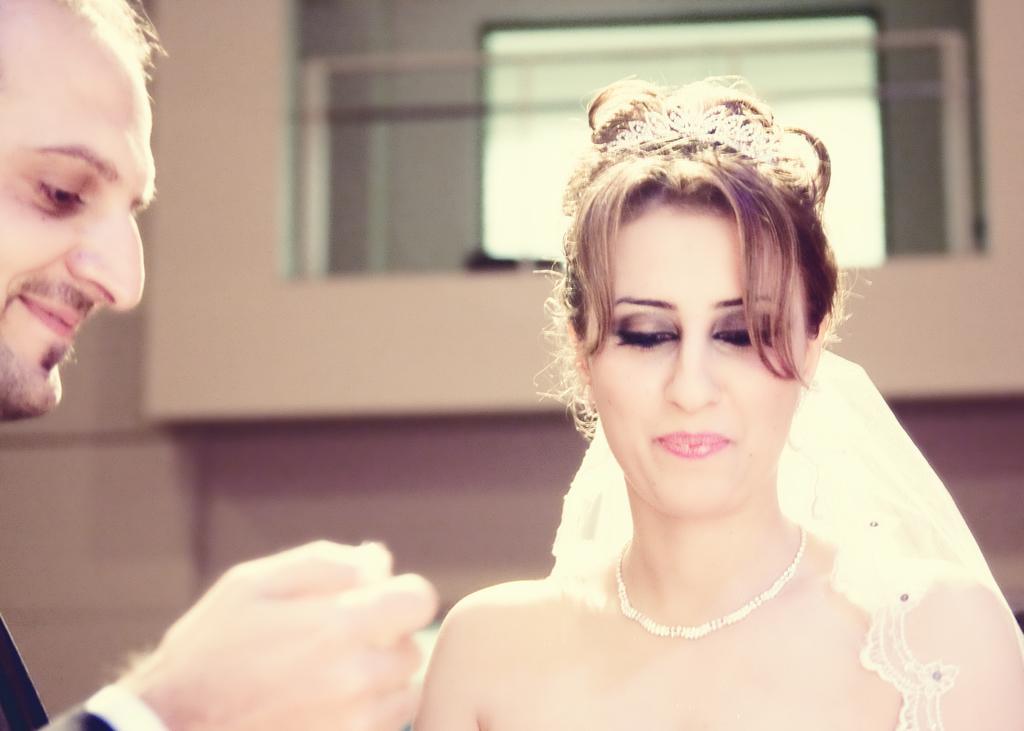In one or two sentences, can you explain what this image depicts? In this image we can see a man and a woman. 